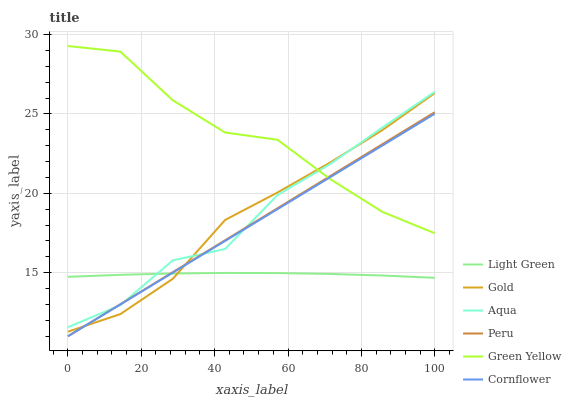Does Light Green have the minimum area under the curve?
Answer yes or no. Yes. Does Green Yellow have the maximum area under the curve?
Answer yes or no. Yes. Does Gold have the minimum area under the curve?
Answer yes or no. No. Does Gold have the maximum area under the curve?
Answer yes or no. No. Is Peru the smoothest?
Answer yes or no. Yes. Is Green Yellow the roughest?
Answer yes or no. Yes. Is Light Green the smoothest?
Answer yes or no. No. Is Light Green the roughest?
Answer yes or no. No. Does Light Green have the lowest value?
Answer yes or no. No. Does Green Yellow have the highest value?
Answer yes or no. Yes. Does Gold have the highest value?
Answer yes or no. No. Is Light Green less than Green Yellow?
Answer yes or no. Yes. Is Green Yellow greater than Light Green?
Answer yes or no. Yes. Does Cornflower intersect Aqua?
Answer yes or no. Yes. Is Cornflower less than Aqua?
Answer yes or no. No. Is Cornflower greater than Aqua?
Answer yes or no. No. Does Light Green intersect Green Yellow?
Answer yes or no. No. 